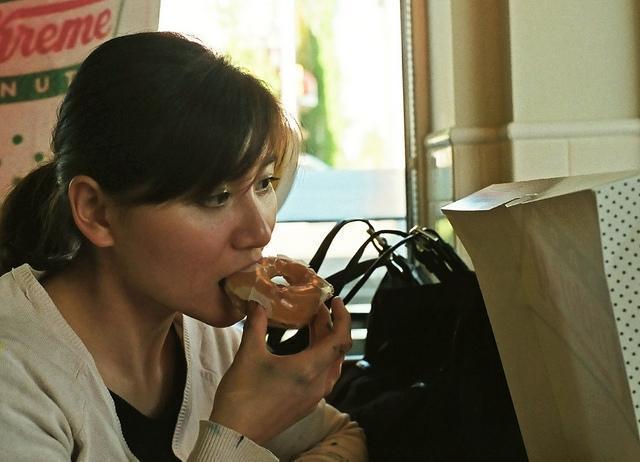How many women are here?
Give a very brief answer. 1. How many doughnuts are there?
Give a very brief answer. 1. How many sandwiches are there?
Give a very brief answer. 0. How many news anchors are on the television screen?
Give a very brief answer. 0. 